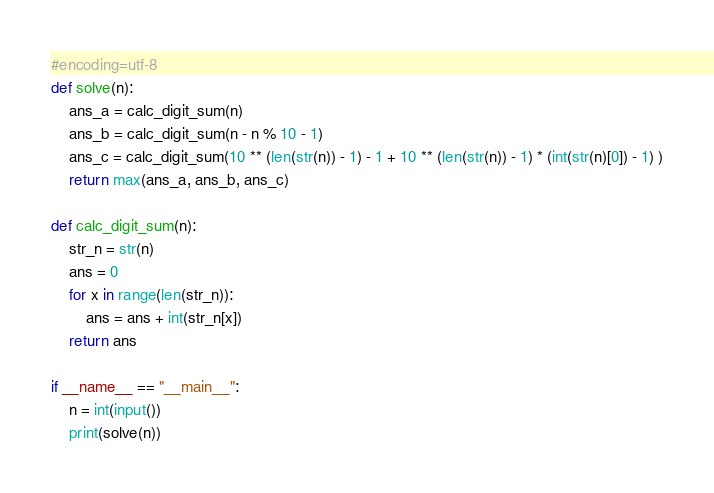<code> <loc_0><loc_0><loc_500><loc_500><_Python_>#encoding=utf-8
def solve(n):
    ans_a = calc_digit_sum(n)
    ans_b = calc_digit_sum(n - n % 10 - 1)
    ans_c = calc_digit_sum(10 ** (len(str(n)) - 1) - 1 + 10 ** (len(str(n)) - 1) * (int(str(n)[0]) - 1) )
    return max(ans_a, ans_b, ans_c)

def calc_digit_sum(n):
    str_n = str(n)
    ans = 0
    for x in range(len(str_n)):
        ans = ans + int(str_n[x])
    return ans

if __name__ == "__main__":
    n = int(input())
    print(solve(n))
</code> 